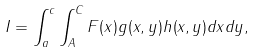<formula> <loc_0><loc_0><loc_500><loc_500>I = \int _ { a } ^ { c } \int _ { A } ^ { C } F ( x ) g ( x , y ) h ( x , y ) d x d y ,</formula> 